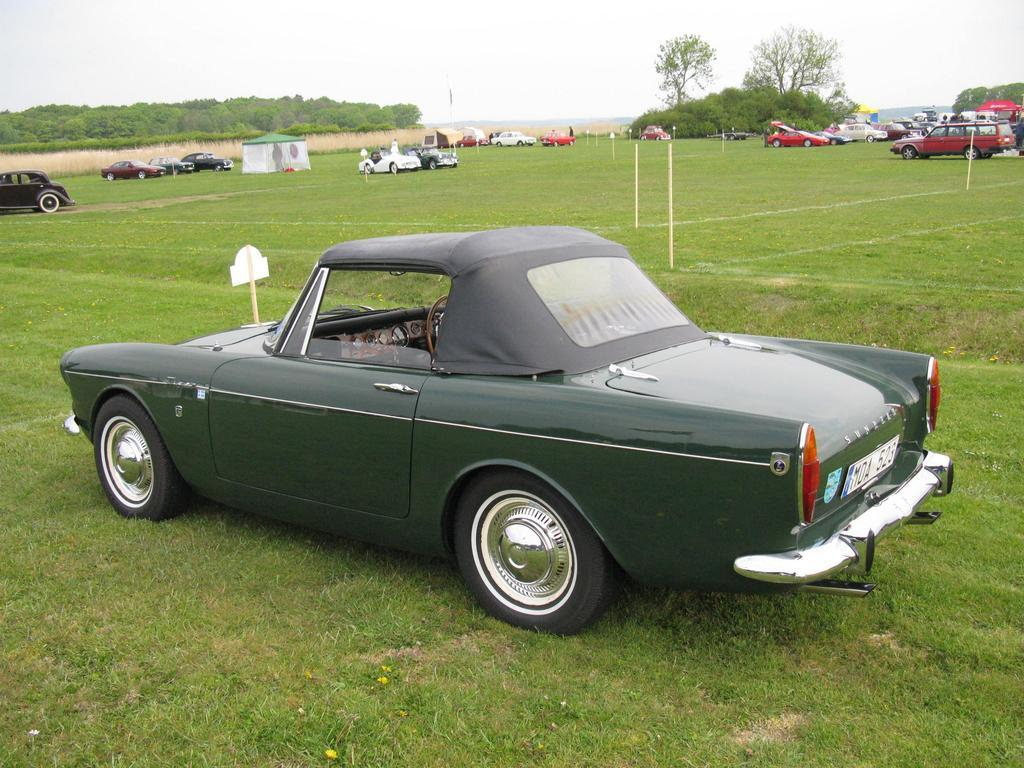What is the location of the vehicles in the image? The vehicles are parked on the grass in the image. How can the vehicles be distinguished from one another? The vehicles are in different colors. What can be seen on the ground near the vehicles? There are white color lines on the ground. What structures are visible in the background of the image? In the background, there are tents and trees. What else can be seen in the background of the image? The sky is visible in the background. What type of quince is being used as a decoration in the image? There is no quince present in the image; it features vehicles parked on the grass with white lines on the ground and tents, trees, and the sky in the background. Can you describe the behavior of the ants in the image? There are no ants present in the image. 